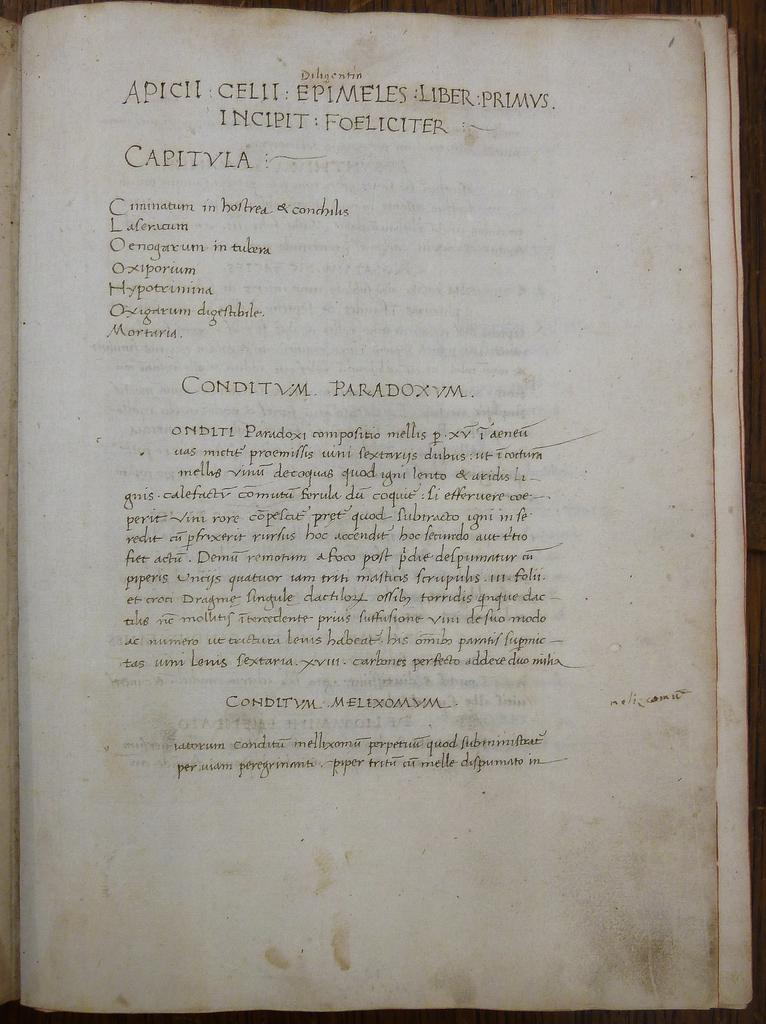<image>
Relay a brief, clear account of the picture shown. a page from a book that says capitvla on it 